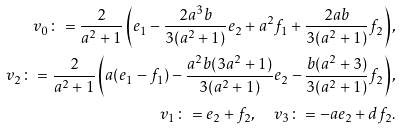<formula> <loc_0><loc_0><loc_500><loc_500>v _ { 0 } \colon = \frac { 2 } { a ^ { 2 } + 1 } \left ( e _ { 1 } - \frac { 2 a ^ { 3 } b } { 3 ( a ^ { 2 } + 1 ) } e _ { 2 } + a ^ { 2 } f _ { 1 } + \frac { 2 a b } { 3 ( a ^ { 2 } + 1 ) } f _ { 2 } \right ) , \\ v _ { 2 } \colon = \frac { 2 } { a ^ { 2 } + 1 } \left ( a ( e _ { 1 } - f _ { 1 } ) - \frac { a ^ { 2 } b ( 3 a ^ { 2 } + 1 ) } { 3 ( a ^ { 2 } + 1 ) } e _ { 2 } - \frac { b ( a ^ { 2 } + 3 ) } { 3 ( a ^ { 2 } + 1 ) } f _ { 2 } \right ) , \\ v _ { 1 } \colon = e _ { 2 } + f _ { 2 } , \quad v _ { 3 } \colon = - a e _ { 2 } + d f _ { 2 } .</formula> 